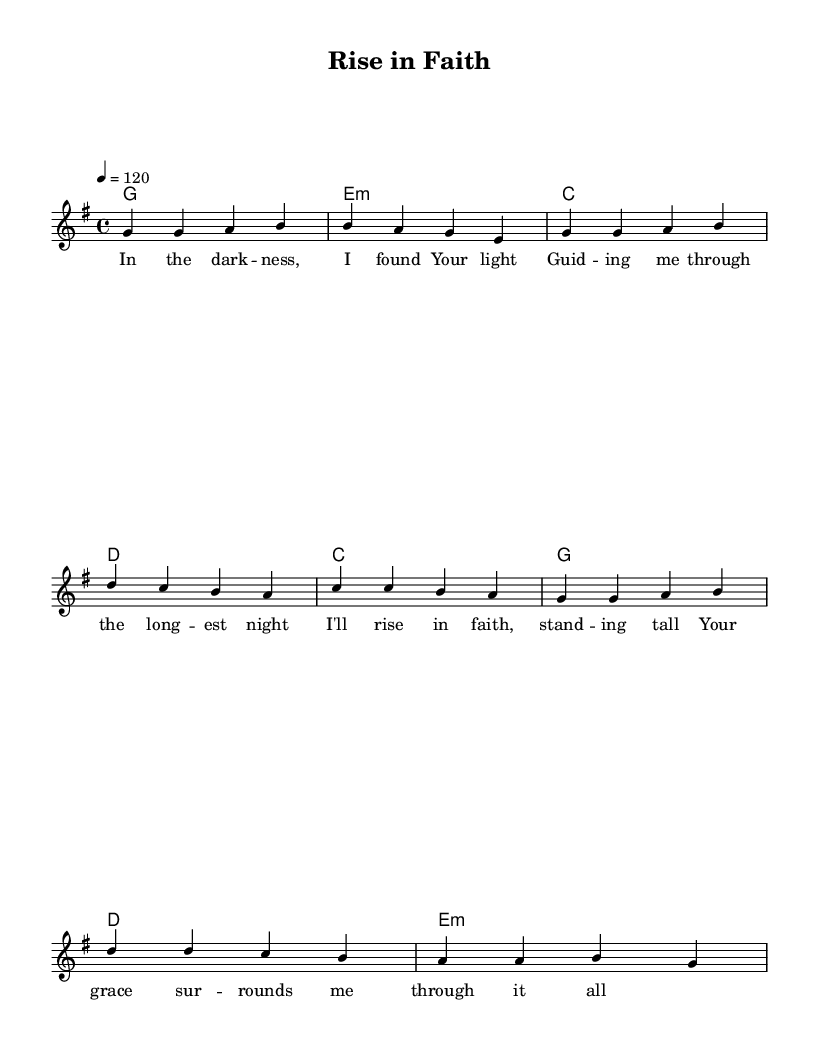What is the key signature of this music? The key signature is G major, which has one sharp (F#). This can be determined from the `\key g \major` indication in the global settings of the LilyPond code.
Answer: G major What is the time signature of this music? The time signature is 4/4, indicated as `\time 4/4` in the global settings of the LilyPond code. This tells us that there are four beats in each measure.
Answer: 4/4 What is the tempo of the piece? The tempo is set to 120 beats per minute, as specified in the `\tempo 4 = 120` line in the code. This means the music should be played at a moderate pace of 120 beats each minute.
Answer: 120 How many measures are in the verse section? The verse section consists of four measures, which can be counted by observing the number of bars in the `\melody` section defined under `verse`. Each group of music is separated by a vertical line, indicating a new measure.
Answer: 4 What chords are used in the chorus? The chords in the chorus are C, G, D, and E minor, as identified in the `\chordmode` section of the code where they appear sequentially. These chords create the harmonic framework for the chorus.
Answer: C, G, D, e:m What is the overall theme conveyed through the lyrics? The overall theme conveyed through the lyrics is one of hope and resilience in faith, emphasizing the presence of light and grace even in darkness. This theme can be derived from phrases like "I found Your light" and "Your grace surrounds me".
Answer: Hope and resilience 